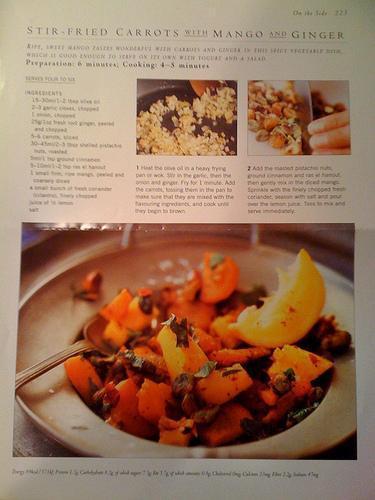How many grapes are in this photo?
Give a very brief answer. 0. 